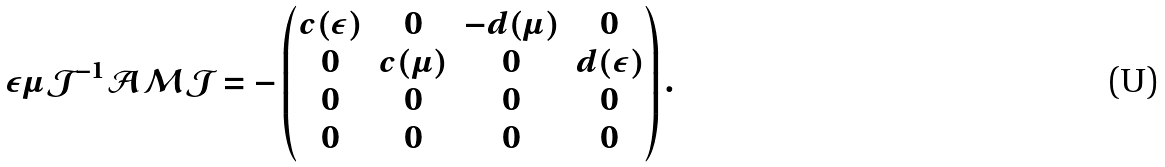<formula> <loc_0><loc_0><loc_500><loc_500>\varepsilon \mu \mathcal { J } ^ { - 1 } \mathcal { A } \mathcal { M } \mathcal { J } = - \begin{pmatrix} c ( \varepsilon ) & 0 & - d ( \mu ) & 0 \\ 0 & c ( \mu ) & 0 & d ( \varepsilon ) \\ 0 & 0 & 0 & 0 \\ 0 & 0 & 0 & 0 \end{pmatrix} .</formula> 